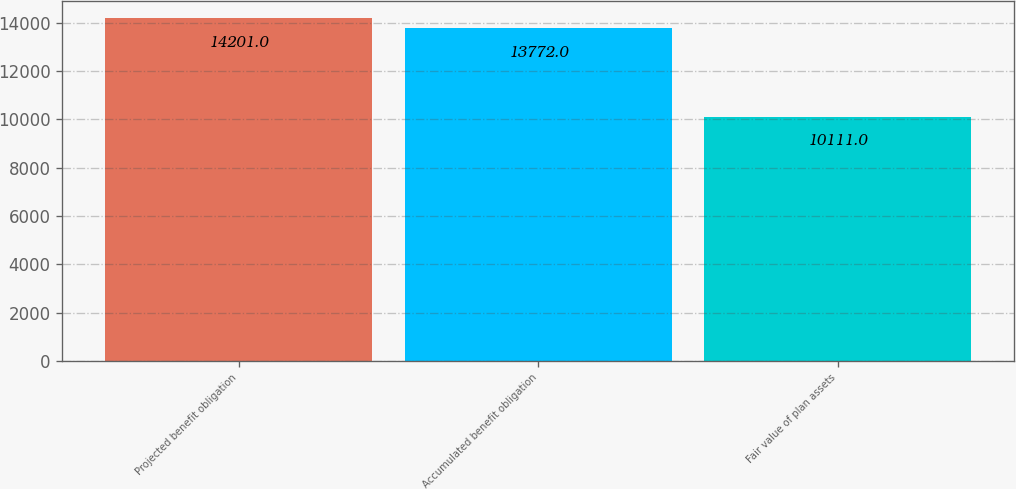<chart> <loc_0><loc_0><loc_500><loc_500><bar_chart><fcel>Projected benefit obligation<fcel>Accumulated benefit obligation<fcel>Fair value of plan assets<nl><fcel>14201<fcel>13772<fcel>10111<nl></chart> 